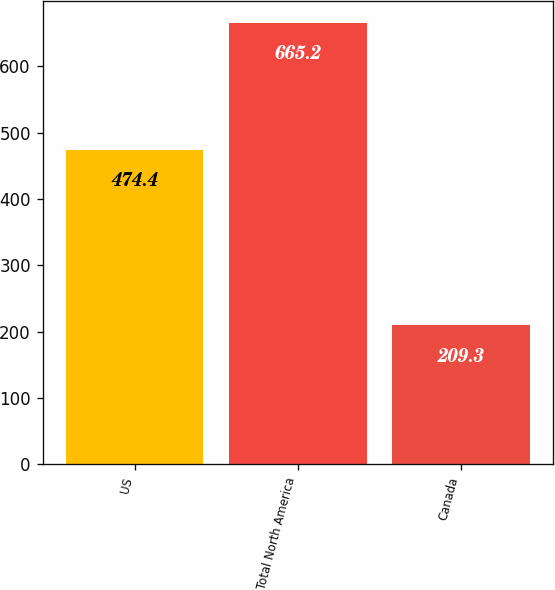Convert chart. <chart><loc_0><loc_0><loc_500><loc_500><bar_chart><fcel>US<fcel>Total North America<fcel>Canada<nl><fcel>474.4<fcel>665.2<fcel>209.3<nl></chart> 